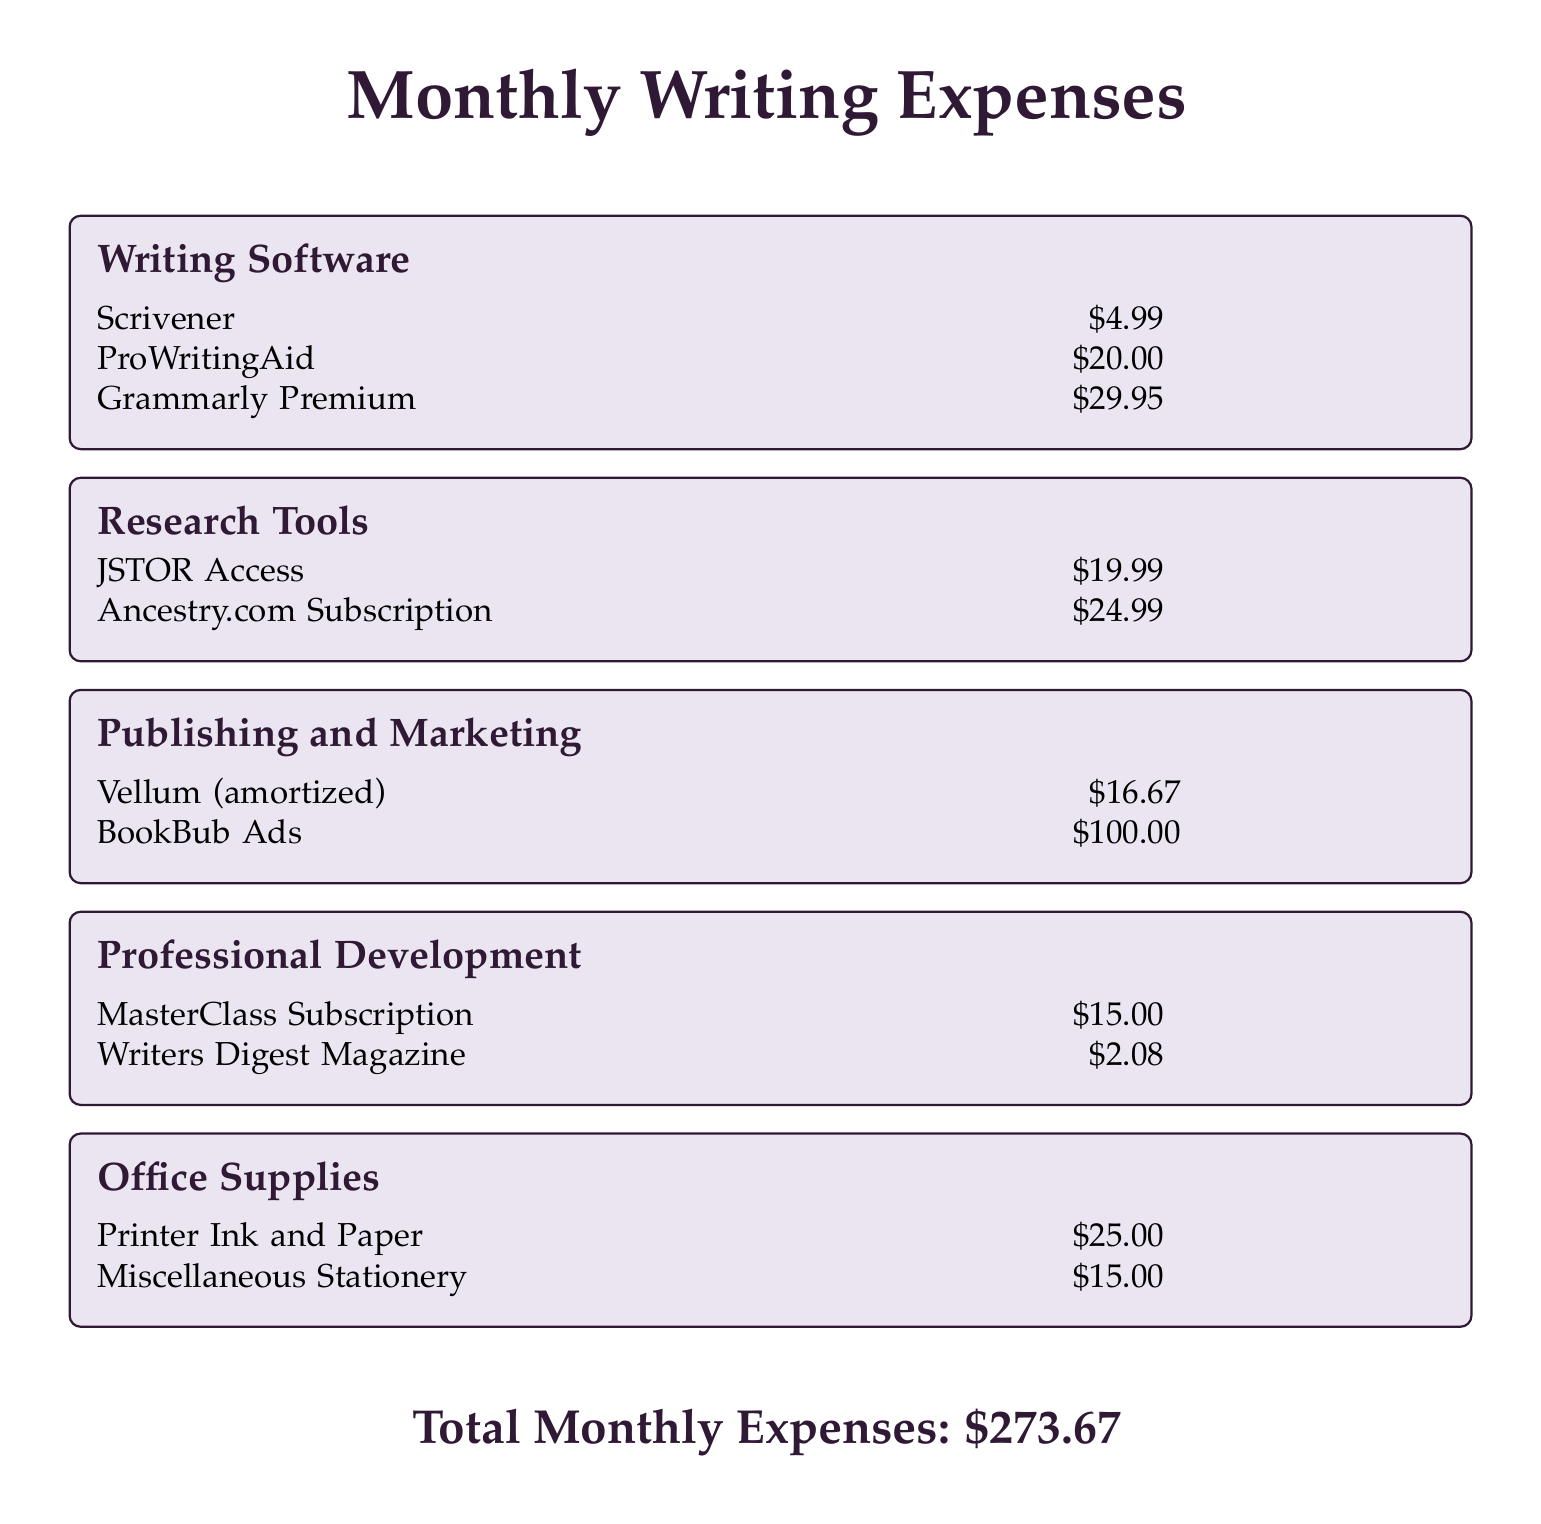What is the monthly expense for Scrivener? Scrivener is listed under Writing Software with a cost of $4.99.
Answer: $4.99 How much does the ProWritingAid subscription cost? ProWritingAid is a writing software listed at $20.00.
Answer: $20.00 What is the total cost for research tools? The total for research tools combines JSTOR Access and Ancestry.com Subscription, which are $19.99 and $24.99 respectively, totaling $44.98.
Answer: $44.98 How much is spent on publishing and marketing? The total for publishing and marketing includes Vellum and BookBub Ads, totaling $116.67.
Answer: $116.67 What is the monthly expense for printer ink and paper? Printer Ink and Paper is listed under Office Supplies with a cost of $25.00.
Answer: $25.00 What is the lowest subscription cost among the mentioned software tools? Grammarly Premium has the highest cost among software tools listed, and ProWritingAid is next at $20.00. Scrivener is the lowest at $4.99.
Answer: $4.99 What is the total monthly expense listed in the document? The total monthly expenses are clearly stated at the bottom of the document as $273.67.
Answer: $273.67 How much is allocated for professional development? The total for professional development combines MasterClass and Writers Digest Magazine, totaling $17.08.
Answer: $17.08 Which subscription costs more, JSTOR Access or Ancestry.com? JSTOR Access is $19.99 while Ancestry.com costs $24.99, making Ancestry.com the more expensive subscription.
Answer: Ancestry.com 